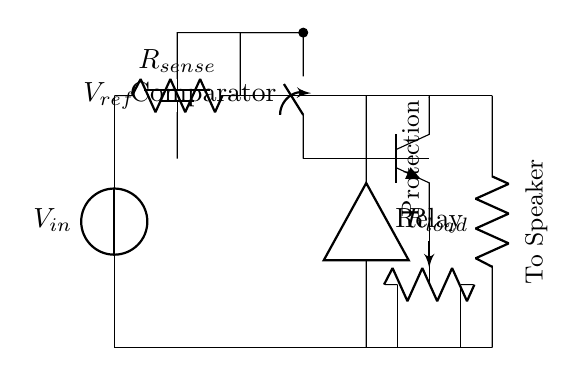What is the role of R sense? R sense is used for current sensing. It detects the current flowing through the circuit, which is crucial for overcurrent protection.
Answer: current sensing What is the type of transistor indicated in the circuit? The transistor is labeled as NPN, indicated by the symbol used in the diagram. This type of transistor is typically used for switching applications, including overcurrent protection.
Answer: NPN What component is used to disconnect the circuit in case of an overcurrent situation? The component responsible for disconnecting the circuit is the relay, which is shown in the diagram. If the current sensing detects an overcurrent, the relay will open the circuit.
Answer: relay What is the reference voltage in this circuit? The reference voltage is shown as V ref in the diagram, which provides the threshold for the comparator to decide whether an overcurrent condition exists.
Answer: V ref How does the comparator function in this circuit? The comparator compares the voltage across R sense with the reference voltage V ref to determine if the current exceeds a predetermined level. If it does, it triggers the transistor to activate the relay for protection.
Answer: compares current What happens when the current exceeds the reference level? When the current exceeds the reference level, the comparator will activate the transistor, which in turn energizes the relay to disconnect the load from the amplifier. This prevents damage due to overcurrent.
Answer: disconnects load What does the label "Protection" indicate in the circuit? The label "Protection" indicates the section of the circuit responsible for preventing overcurrent conditions. It encompasses components such as the comparator, relay, and transistor that work together to safeguard the amplifier.
Answer: overcurrent protection 